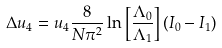Convert formula to latex. <formula><loc_0><loc_0><loc_500><loc_500>\Delta u _ { 4 } = u _ { 4 } \frac { 8 } { N \pi ^ { 2 } } \ln \left [ \frac { \Lambda _ { 0 } } { \Lambda _ { 1 } } \right ] ( I _ { 0 } - I _ { 1 } )</formula> 